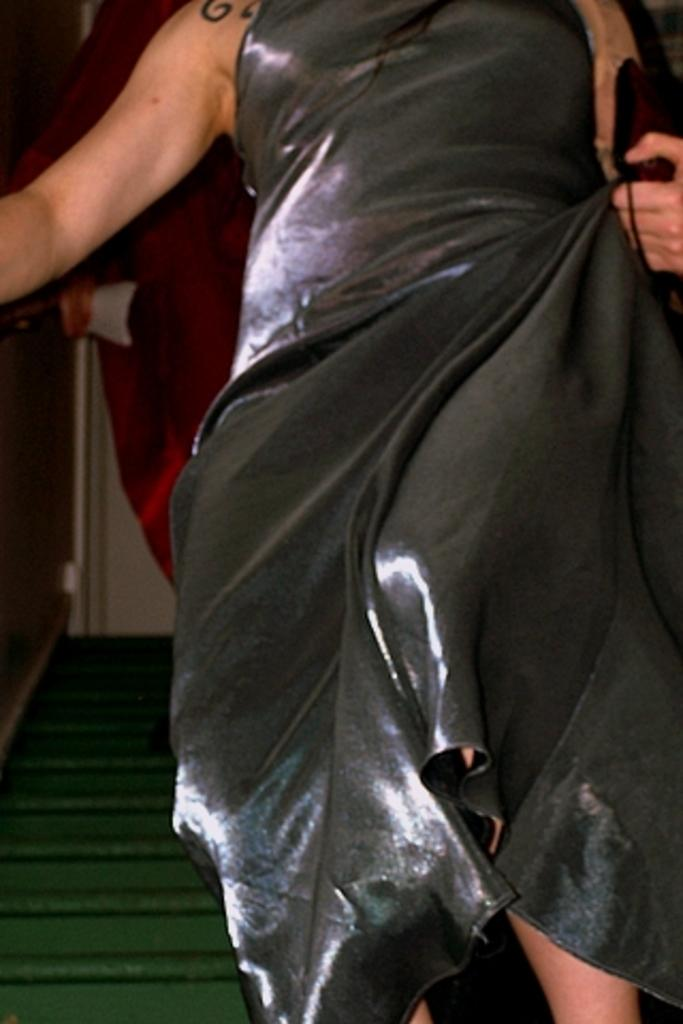Who is the main subject in the image? There is a lady in the image. What can be seen in the background of the image? There are stairs in the background of the image. What type of powder is being used by the lady in the image? There is no powder visible in the image, and the lady's actions are not described, so it cannot be determined if she is using any powder. 